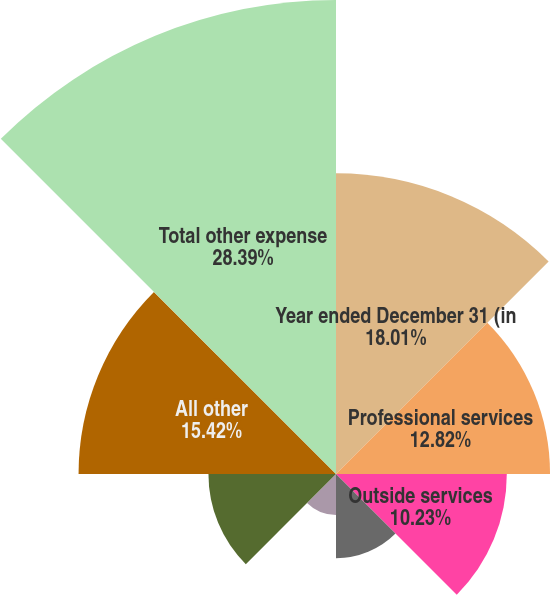<chart> <loc_0><loc_0><loc_500><loc_500><pie_chart><fcel>Year ended December 31 (in<fcel>Professional services<fcel>Outside services<fcel>Marketing<fcel>Travel and entertainment<fcel>Amortization of intangibles<fcel>All other<fcel>Total other expense<nl><fcel>18.01%<fcel>12.82%<fcel>10.23%<fcel>5.04%<fcel>2.45%<fcel>7.64%<fcel>15.42%<fcel>28.39%<nl></chart> 